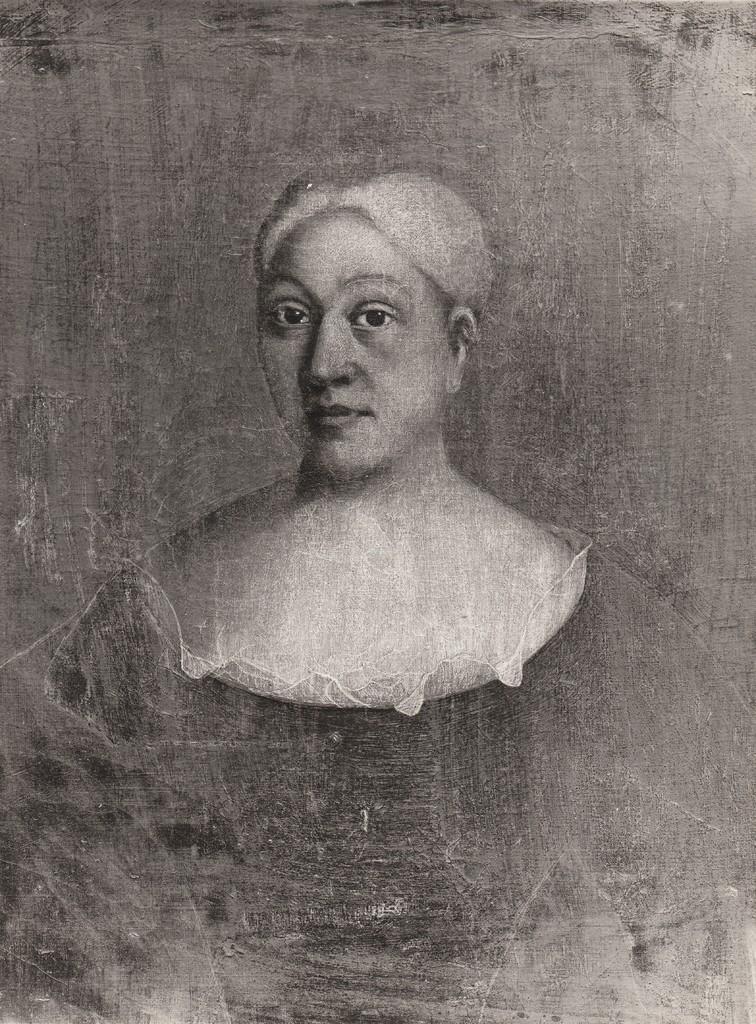Can you describe this image briefly? This picture shows a painting of a woman. 